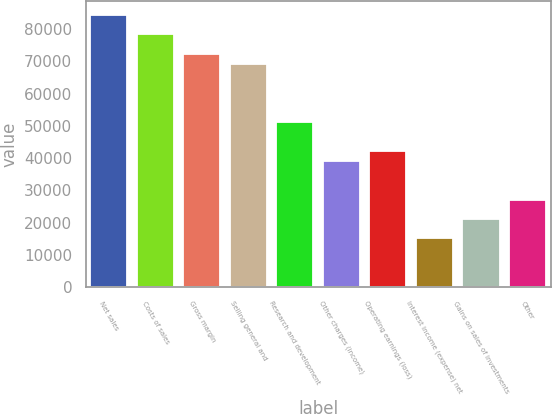Convert chart to OTSL. <chart><loc_0><loc_0><loc_500><loc_500><bar_chart><fcel>Net sales<fcel>Costs of sales<fcel>Gross margin<fcel>Selling general and<fcel>Research and development<fcel>Other charges (income)<fcel>Operating earnings (loss)<fcel>Interest income (expense) net<fcel>Gains on sales of investments<fcel>Other<nl><fcel>84408.4<fcel>78379.3<fcel>72350.1<fcel>69335.5<fcel>51248.1<fcel>39189.7<fcel>42204.3<fcel>15073.1<fcel>21102.3<fcel>27131.4<nl></chart> 